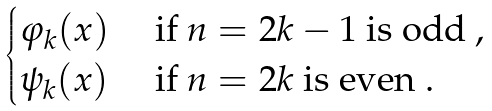<formula> <loc_0><loc_0><loc_500><loc_500>\begin{cases} \varphi _ { k } ( x ) & \text { if } n = 2 k - 1 \text { is odd } , \\ \psi _ { k } ( x ) & \text { if } n = 2 k \text { is even } . \end{cases}</formula> 